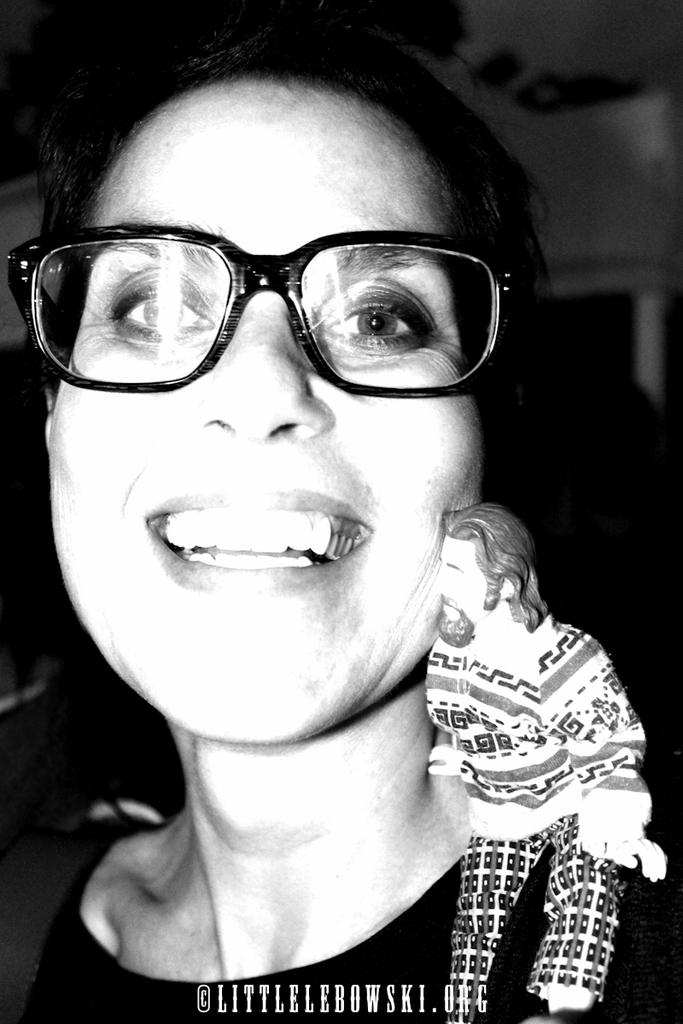What is the color scheme of the image? The image is black and white. Who is present in the image? There is a woman in the image. What accessory is the woman wearing? The woman is wearing spectacles. What can be seen on the woman's right shoulder? There is a sculpture on the woman's right shoulder. What channel is the woman watching on her elbow in the image? There is no television or channel present in the image, and the woman's elbow is not mentioned as a location for any activity. 